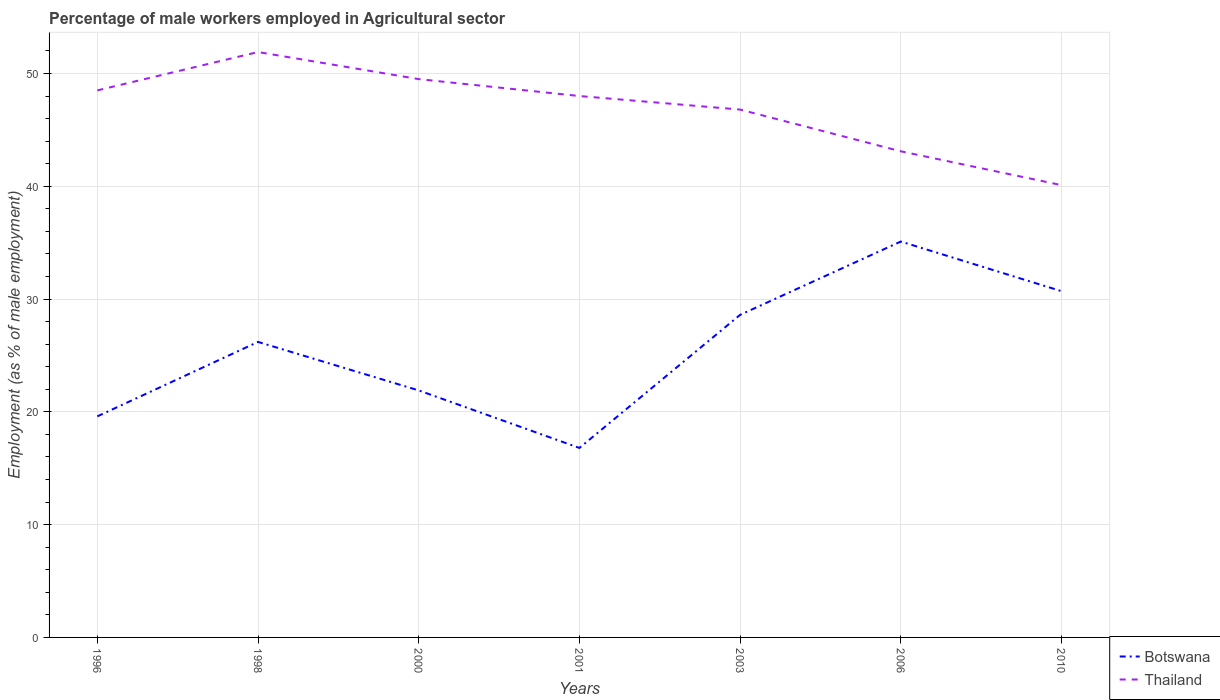How many different coloured lines are there?
Offer a terse response. 2. Does the line corresponding to Botswana intersect with the line corresponding to Thailand?
Your answer should be compact. No. Across all years, what is the maximum percentage of male workers employed in Agricultural sector in Thailand?
Provide a short and direct response. 40.1. What is the total percentage of male workers employed in Agricultural sector in Botswana in the graph?
Offer a terse response. -13.2. What is the difference between the highest and the second highest percentage of male workers employed in Agricultural sector in Thailand?
Provide a short and direct response. 11.8. What is the difference between the highest and the lowest percentage of male workers employed in Agricultural sector in Botswana?
Keep it short and to the point. 4. Is the percentage of male workers employed in Agricultural sector in Thailand strictly greater than the percentage of male workers employed in Agricultural sector in Botswana over the years?
Keep it short and to the point. No. How many years are there in the graph?
Your answer should be very brief. 7. What is the difference between two consecutive major ticks on the Y-axis?
Your response must be concise. 10. Does the graph contain grids?
Provide a short and direct response. Yes. How many legend labels are there?
Make the answer very short. 2. How are the legend labels stacked?
Provide a succinct answer. Vertical. What is the title of the graph?
Offer a terse response. Percentage of male workers employed in Agricultural sector. What is the label or title of the X-axis?
Your answer should be very brief. Years. What is the label or title of the Y-axis?
Provide a succinct answer. Employment (as % of male employment). What is the Employment (as % of male employment) in Botswana in 1996?
Offer a terse response. 19.6. What is the Employment (as % of male employment) in Thailand in 1996?
Your answer should be very brief. 48.5. What is the Employment (as % of male employment) in Botswana in 1998?
Provide a short and direct response. 26.2. What is the Employment (as % of male employment) in Thailand in 1998?
Your answer should be very brief. 51.9. What is the Employment (as % of male employment) in Botswana in 2000?
Your answer should be compact. 21.9. What is the Employment (as % of male employment) of Thailand in 2000?
Your answer should be compact. 49.5. What is the Employment (as % of male employment) of Botswana in 2001?
Provide a short and direct response. 16.8. What is the Employment (as % of male employment) in Thailand in 2001?
Your answer should be very brief. 48. What is the Employment (as % of male employment) of Botswana in 2003?
Your answer should be very brief. 28.6. What is the Employment (as % of male employment) in Thailand in 2003?
Give a very brief answer. 46.8. What is the Employment (as % of male employment) in Botswana in 2006?
Your response must be concise. 35.1. What is the Employment (as % of male employment) of Thailand in 2006?
Provide a short and direct response. 43.1. What is the Employment (as % of male employment) of Botswana in 2010?
Ensure brevity in your answer.  30.7. What is the Employment (as % of male employment) in Thailand in 2010?
Offer a very short reply. 40.1. Across all years, what is the maximum Employment (as % of male employment) of Botswana?
Give a very brief answer. 35.1. Across all years, what is the maximum Employment (as % of male employment) of Thailand?
Offer a very short reply. 51.9. Across all years, what is the minimum Employment (as % of male employment) of Botswana?
Ensure brevity in your answer.  16.8. Across all years, what is the minimum Employment (as % of male employment) in Thailand?
Keep it short and to the point. 40.1. What is the total Employment (as % of male employment) in Botswana in the graph?
Your response must be concise. 178.9. What is the total Employment (as % of male employment) in Thailand in the graph?
Your response must be concise. 327.9. What is the difference between the Employment (as % of male employment) of Botswana in 1996 and that in 2000?
Offer a very short reply. -2.3. What is the difference between the Employment (as % of male employment) of Thailand in 1996 and that in 2000?
Ensure brevity in your answer.  -1. What is the difference between the Employment (as % of male employment) of Botswana in 1996 and that in 2006?
Provide a succinct answer. -15.5. What is the difference between the Employment (as % of male employment) in Botswana in 1996 and that in 2010?
Your answer should be compact. -11.1. What is the difference between the Employment (as % of male employment) in Botswana in 1998 and that in 2001?
Offer a terse response. 9.4. What is the difference between the Employment (as % of male employment) of Thailand in 1998 and that in 2001?
Your response must be concise. 3.9. What is the difference between the Employment (as % of male employment) in Botswana in 1998 and that in 2003?
Give a very brief answer. -2.4. What is the difference between the Employment (as % of male employment) in Botswana in 1998 and that in 2006?
Ensure brevity in your answer.  -8.9. What is the difference between the Employment (as % of male employment) of Thailand in 1998 and that in 2006?
Your answer should be compact. 8.8. What is the difference between the Employment (as % of male employment) in Botswana in 1998 and that in 2010?
Keep it short and to the point. -4.5. What is the difference between the Employment (as % of male employment) of Thailand in 1998 and that in 2010?
Your answer should be very brief. 11.8. What is the difference between the Employment (as % of male employment) in Botswana in 2000 and that in 2003?
Make the answer very short. -6.7. What is the difference between the Employment (as % of male employment) of Botswana in 2000 and that in 2010?
Your response must be concise. -8.8. What is the difference between the Employment (as % of male employment) in Thailand in 2000 and that in 2010?
Your response must be concise. 9.4. What is the difference between the Employment (as % of male employment) of Botswana in 2001 and that in 2003?
Make the answer very short. -11.8. What is the difference between the Employment (as % of male employment) of Botswana in 2001 and that in 2006?
Provide a short and direct response. -18.3. What is the difference between the Employment (as % of male employment) of Thailand in 2001 and that in 2006?
Make the answer very short. 4.9. What is the difference between the Employment (as % of male employment) of Thailand in 2003 and that in 2006?
Provide a short and direct response. 3.7. What is the difference between the Employment (as % of male employment) of Botswana in 2003 and that in 2010?
Ensure brevity in your answer.  -2.1. What is the difference between the Employment (as % of male employment) of Thailand in 2006 and that in 2010?
Keep it short and to the point. 3. What is the difference between the Employment (as % of male employment) in Botswana in 1996 and the Employment (as % of male employment) in Thailand in 1998?
Your response must be concise. -32.3. What is the difference between the Employment (as % of male employment) in Botswana in 1996 and the Employment (as % of male employment) in Thailand in 2000?
Provide a succinct answer. -29.9. What is the difference between the Employment (as % of male employment) of Botswana in 1996 and the Employment (as % of male employment) of Thailand in 2001?
Make the answer very short. -28.4. What is the difference between the Employment (as % of male employment) of Botswana in 1996 and the Employment (as % of male employment) of Thailand in 2003?
Provide a short and direct response. -27.2. What is the difference between the Employment (as % of male employment) in Botswana in 1996 and the Employment (as % of male employment) in Thailand in 2006?
Give a very brief answer. -23.5. What is the difference between the Employment (as % of male employment) in Botswana in 1996 and the Employment (as % of male employment) in Thailand in 2010?
Give a very brief answer. -20.5. What is the difference between the Employment (as % of male employment) of Botswana in 1998 and the Employment (as % of male employment) of Thailand in 2000?
Give a very brief answer. -23.3. What is the difference between the Employment (as % of male employment) of Botswana in 1998 and the Employment (as % of male employment) of Thailand in 2001?
Provide a succinct answer. -21.8. What is the difference between the Employment (as % of male employment) of Botswana in 1998 and the Employment (as % of male employment) of Thailand in 2003?
Your answer should be very brief. -20.6. What is the difference between the Employment (as % of male employment) of Botswana in 1998 and the Employment (as % of male employment) of Thailand in 2006?
Provide a succinct answer. -16.9. What is the difference between the Employment (as % of male employment) of Botswana in 2000 and the Employment (as % of male employment) of Thailand in 2001?
Your answer should be compact. -26.1. What is the difference between the Employment (as % of male employment) in Botswana in 2000 and the Employment (as % of male employment) in Thailand in 2003?
Offer a very short reply. -24.9. What is the difference between the Employment (as % of male employment) in Botswana in 2000 and the Employment (as % of male employment) in Thailand in 2006?
Your answer should be compact. -21.2. What is the difference between the Employment (as % of male employment) of Botswana in 2000 and the Employment (as % of male employment) of Thailand in 2010?
Provide a succinct answer. -18.2. What is the difference between the Employment (as % of male employment) in Botswana in 2001 and the Employment (as % of male employment) in Thailand in 2006?
Offer a terse response. -26.3. What is the difference between the Employment (as % of male employment) in Botswana in 2001 and the Employment (as % of male employment) in Thailand in 2010?
Offer a very short reply. -23.3. What is the difference between the Employment (as % of male employment) of Botswana in 2003 and the Employment (as % of male employment) of Thailand in 2006?
Keep it short and to the point. -14.5. What is the difference between the Employment (as % of male employment) of Botswana in 2006 and the Employment (as % of male employment) of Thailand in 2010?
Provide a succinct answer. -5. What is the average Employment (as % of male employment) of Botswana per year?
Keep it short and to the point. 25.56. What is the average Employment (as % of male employment) of Thailand per year?
Provide a short and direct response. 46.84. In the year 1996, what is the difference between the Employment (as % of male employment) of Botswana and Employment (as % of male employment) of Thailand?
Give a very brief answer. -28.9. In the year 1998, what is the difference between the Employment (as % of male employment) of Botswana and Employment (as % of male employment) of Thailand?
Your answer should be compact. -25.7. In the year 2000, what is the difference between the Employment (as % of male employment) of Botswana and Employment (as % of male employment) of Thailand?
Your response must be concise. -27.6. In the year 2001, what is the difference between the Employment (as % of male employment) in Botswana and Employment (as % of male employment) in Thailand?
Keep it short and to the point. -31.2. In the year 2003, what is the difference between the Employment (as % of male employment) of Botswana and Employment (as % of male employment) of Thailand?
Your answer should be very brief. -18.2. What is the ratio of the Employment (as % of male employment) in Botswana in 1996 to that in 1998?
Your answer should be compact. 0.75. What is the ratio of the Employment (as % of male employment) of Thailand in 1996 to that in 1998?
Offer a very short reply. 0.93. What is the ratio of the Employment (as % of male employment) of Botswana in 1996 to that in 2000?
Offer a terse response. 0.9. What is the ratio of the Employment (as % of male employment) of Thailand in 1996 to that in 2000?
Your answer should be compact. 0.98. What is the ratio of the Employment (as % of male employment) of Botswana in 1996 to that in 2001?
Your answer should be very brief. 1.17. What is the ratio of the Employment (as % of male employment) of Thailand in 1996 to that in 2001?
Your answer should be compact. 1.01. What is the ratio of the Employment (as % of male employment) of Botswana in 1996 to that in 2003?
Make the answer very short. 0.69. What is the ratio of the Employment (as % of male employment) of Thailand in 1996 to that in 2003?
Ensure brevity in your answer.  1.04. What is the ratio of the Employment (as % of male employment) of Botswana in 1996 to that in 2006?
Your response must be concise. 0.56. What is the ratio of the Employment (as % of male employment) of Thailand in 1996 to that in 2006?
Provide a succinct answer. 1.13. What is the ratio of the Employment (as % of male employment) of Botswana in 1996 to that in 2010?
Offer a terse response. 0.64. What is the ratio of the Employment (as % of male employment) of Thailand in 1996 to that in 2010?
Provide a short and direct response. 1.21. What is the ratio of the Employment (as % of male employment) in Botswana in 1998 to that in 2000?
Ensure brevity in your answer.  1.2. What is the ratio of the Employment (as % of male employment) in Thailand in 1998 to that in 2000?
Give a very brief answer. 1.05. What is the ratio of the Employment (as % of male employment) of Botswana in 1998 to that in 2001?
Offer a terse response. 1.56. What is the ratio of the Employment (as % of male employment) of Thailand in 1998 to that in 2001?
Offer a terse response. 1.08. What is the ratio of the Employment (as % of male employment) in Botswana in 1998 to that in 2003?
Offer a terse response. 0.92. What is the ratio of the Employment (as % of male employment) in Thailand in 1998 to that in 2003?
Provide a short and direct response. 1.11. What is the ratio of the Employment (as % of male employment) in Botswana in 1998 to that in 2006?
Your response must be concise. 0.75. What is the ratio of the Employment (as % of male employment) of Thailand in 1998 to that in 2006?
Your answer should be compact. 1.2. What is the ratio of the Employment (as % of male employment) in Botswana in 1998 to that in 2010?
Make the answer very short. 0.85. What is the ratio of the Employment (as % of male employment) in Thailand in 1998 to that in 2010?
Your answer should be very brief. 1.29. What is the ratio of the Employment (as % of male employment) of Botswana in 2000 to that in 2001?
Give a very brief answer. 1.3. What is the ratio of the Employment (as % of male employment) of Thailand in 2000 to that in 2001?
Offer a very short reply. 1.03. What is the ratio of the Employment (as % of male employment) in Botswana in 2000 to that in 2003?
Provide a short and direct response. 0.77. What is the ratio of the Employment (as % of male employment) in Thailand in 2000 to that in 2003?
Offer a terse response. 1.06. What is the ratio of the Employment (as % of male employment) in Botswana in 2000 to that in 2006?
Your answer should be compact. 0.62. What is the ratio of the Employment (as % of male employment) of Thailand in 2000 to that in 2006?
Provide a succinct answer. 1.15. What is the ratio of the Employment (as % of male employment) in Botswana in 2000 to that in 2010?
Your answer should be very brief. 0.71. What is the ratio of the Employment (as % of male employment) of Thailand in 2000 to that in 2010?
Provide a short and direct response. 1.23. What is the ratio of the Employment (as % of male employment) in Botswana in 2001 to that in 2003?
Ensure brevity in your answer.  0.59. What is the ratio of the Employment (as % of male employment) of Thailand in 2001 to that in 2003?
Provide a short and direct response. 1.03. What is the ratio of the Employment (as % of male employment) in Botswana in 2001 to that in 2006?
Give a very brief answer. 0.48. What is the ratio of the Employment (as % of male employment) in Thailand in 2001 to that in 2006?
Your answer should be very brief. 1.11. What is the ratio of the Employment (as % of male employment) in Botswana in 2001 to that in 2010?
Ensure brevity in your answer.  0.55. What is the ratio of the Employment (as % of male employment) in Thailand in 2001 to that in 2010?
Ensure brevity in your answer.  1.2. What is the ratio of the Employment (as % of male employment) of Botswana in 2003 to that in 2006?
Offer a terse response. 0.81. What is the ratio of the Employment (as % of male employment) of Thailand in 2003 to that in 2006?
Ensure brevity in your answer.  1.09. What is the ratio of the Employment (as % of male employment) in Botswana in 2003 to that in 2010?
Offer a very short reply. 0.93. What is the ratio of the Employment (as % of male employment) in Thailand in 2003 to that in 2010?
Give a very brief answer. 1.17. What is the ratio of the Employment (as % of male employment) in Botswana in 2006 to that in 2010?
Provide a succinct answer. 1.14. What is the ratio of the Employment (as % of male employment) in Thailand in 2006 to that in 2010?
Provide a short and direct response. 1.07. What is the difference between the highest and the lowest Employment (as % of male employment) in Thailand?
Offer a terse response. 11.8. 